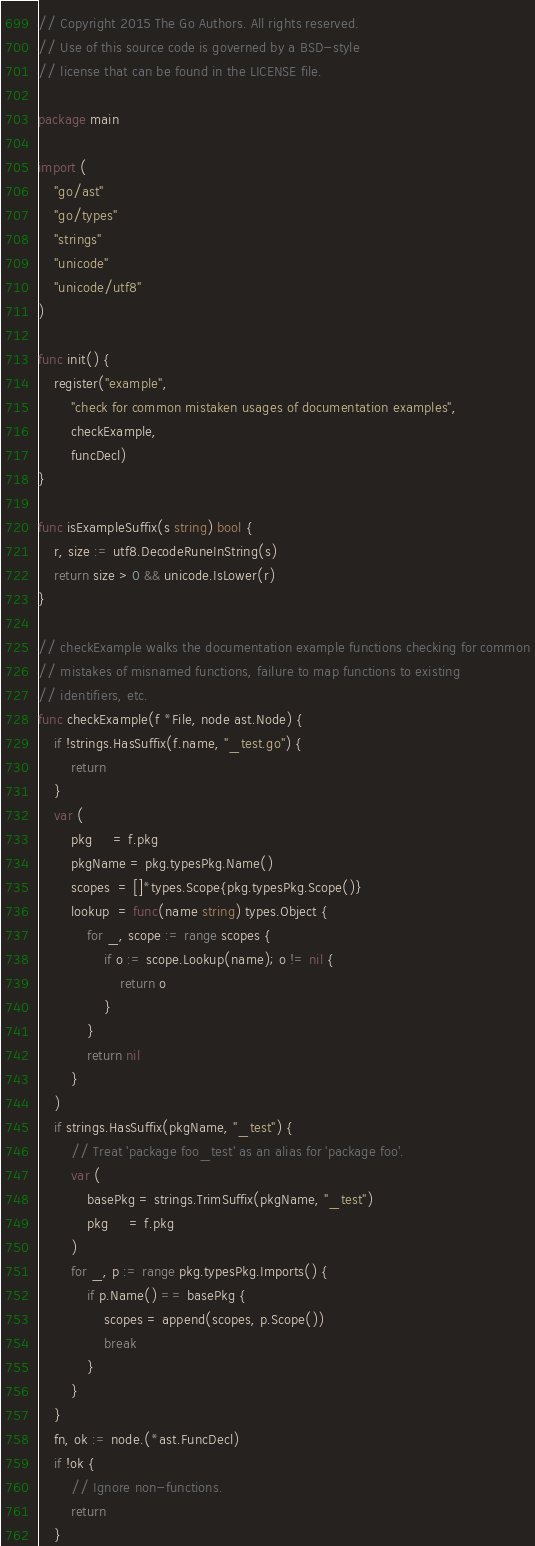Convert code to text. <code><loc_0><loc_0><loc_500><loc_500><_Go_>// Copyright 2015 The Go Authors. All rights reserved.
// Use of this source code is governed by a BSD-style
// license that can be found in the LICENSE file.

package main

import (
	"go/ast"
	"go/types"
	"strings"
	"unicode"
	"unicode/utf8"
)

func init() {
	register("example",
		"check for common mistaken usages of documentation examples",
		checkExample,
		funcDecl)
}

func isExampleSuffix(s string) bool {
	r, size := utf8.DecodeRuneInString(s)
	return size > 0 && unicode.IsLower(r)
}

// checkExample walks the documentation example functions checking for common
// mistakes of misnamed functions, failure to map functions to existing
// identifiers, etc.
func checkExample(f *File, node ast.Node) {
	if !strings.HasSuffix(f.name, "_test.go") {
		return
	}
	var (
		pkg     = f.pkg
		pkgName = pkg.typesPkg.Name()
		scopes  = []*types.Scope{pkg.typesPkg.Scope()}
		lookup  = func(name string) types.Object {
			for _, scope := range scopes {
				if o := scope.Lookup(name); o != nil {
					return o
				}
			}
			return nil
		}
	)
	if strings.HasSuffix(pkgName, "_test") {
		// Treat 'package foo_test' as an alias for 'package foo'.
		var (
			basePkg = strings.TrimSuffix(pkgName, "_test")
			pkg     = f.pkg
		)
		for _, p := range pkg.typesPkg.Imports() {
			if p.Name() == basePkg {
				scopes = append(scopes, p.Scope())
				break
			}
		}
	}
	fn, ok := node.(*ast.FuncDecl)
	if !ok {
		// Ignore non-functions.
		return
	}</code> 